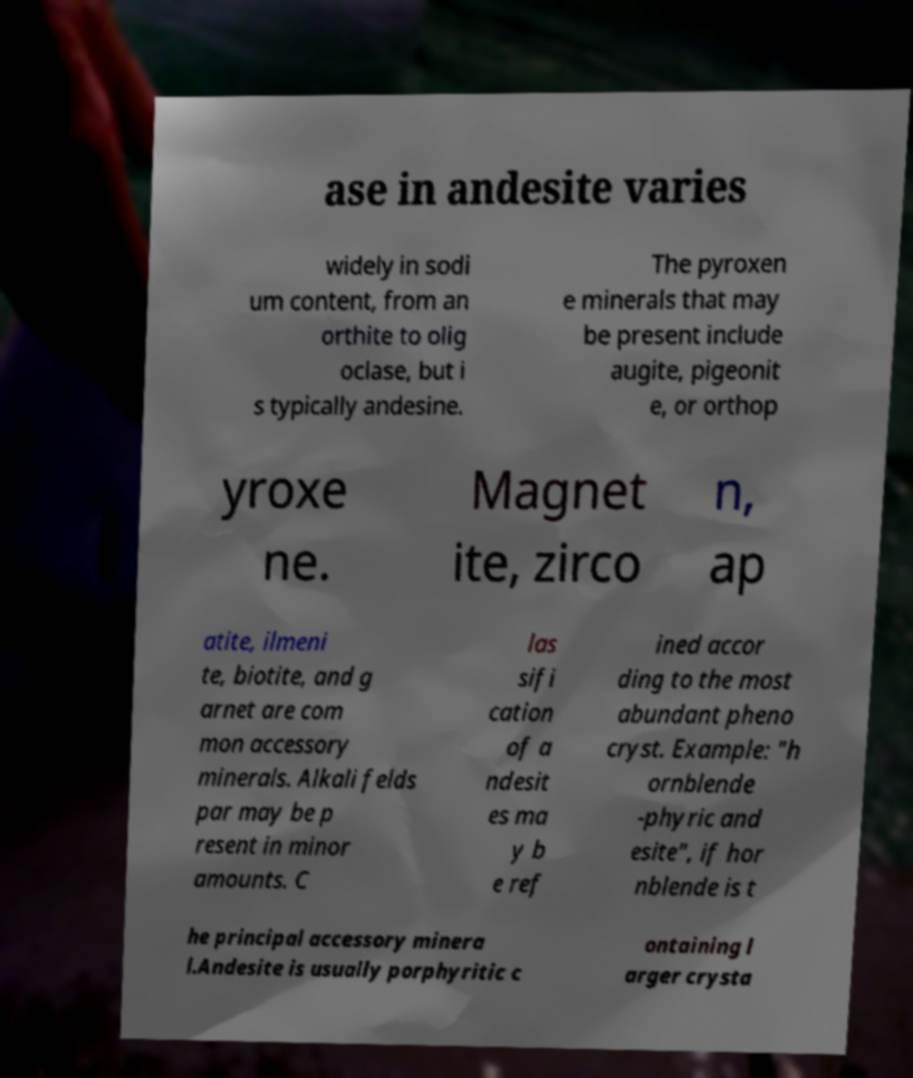I need the written content from this picture converted into text. Can you do that? ase in andesite varies widely in sodi um content, from an orthite to olig oclase, but i s typically andesine. The pyroxen e minerals that may be present include augite, pigeonit e, or orthop yroxe ne. Magnet ite, zirco n, ap atite, ilmeni te, biotite, and g arnet are com mon accessory minerals. Alkali felds par may be p resent in minor amounts. C las sifi cation of a ndesit es ma y b e ref ined accor ding to the most abundant pheno cryst. Example: "h ornblende -phyric and esite", if hor nblende is t he principal accessory minera l.Andesite is usually porphyritic c ontaining l arger crysta 